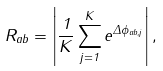Convert formula to latex. <formula><loc_0><loc_0><loc_500><loc_500>R _ { a b } = \left | \frac { 1 } { K } \sum _ { j = 1 } ^ { K } { e ^ { \Delta \phi _ { a b , j } } } \right | ,</formula> 